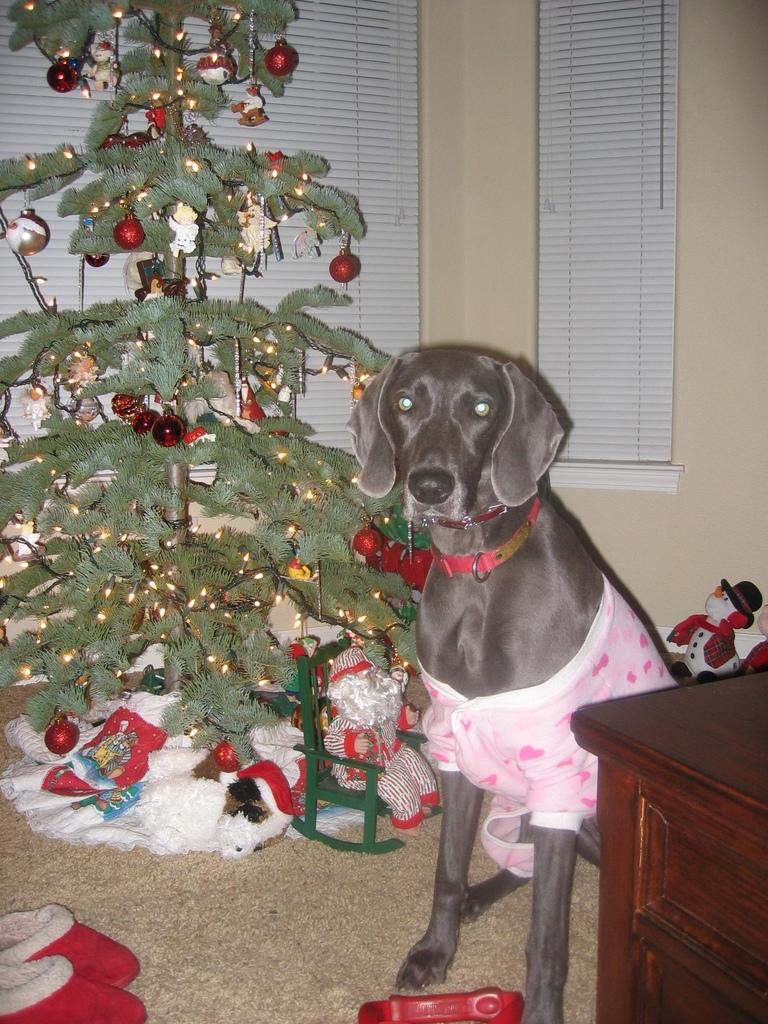What type of animal is present in the image? There is a dog in the picture. What seasonal decoration can be seen in the image? There is a Christmas tree in the picture. What type of ink is used to decorate the dog in the image? There is no ink or decoration on the dog in the image; it is a regular dog. What type of operation is being performed on the Christmas tree in the image? There is no operation being performed on the Christmas tree in the image; it is a stationary decoration. 